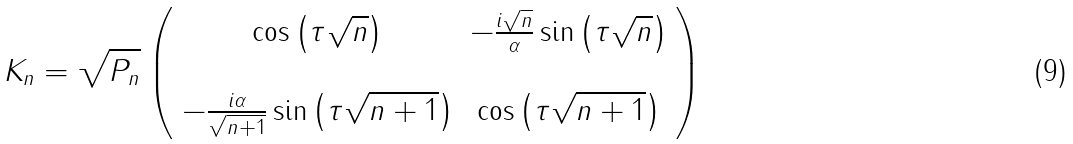<formula> <loc_0><loc_0><loc_500><loc_500>K _ { n } = \sqrt { P _ { n } } \left ( \begin{array} { c c } \cos \left ( \tau \sqrt { n } \right ) & - \frac { i \sqrt { n } } { \alpha } \sin \left ( \tau \sqrt { n } \right ) \\ \\ - \frac { i \alpha } { \sqrt { n + 1 } } \sin \left ( \tau \sqrt { n + 1 } \right ) & \cos \left ( \tau \sqrt { n + 1 } \right ) \end{array} \right )</formula> 